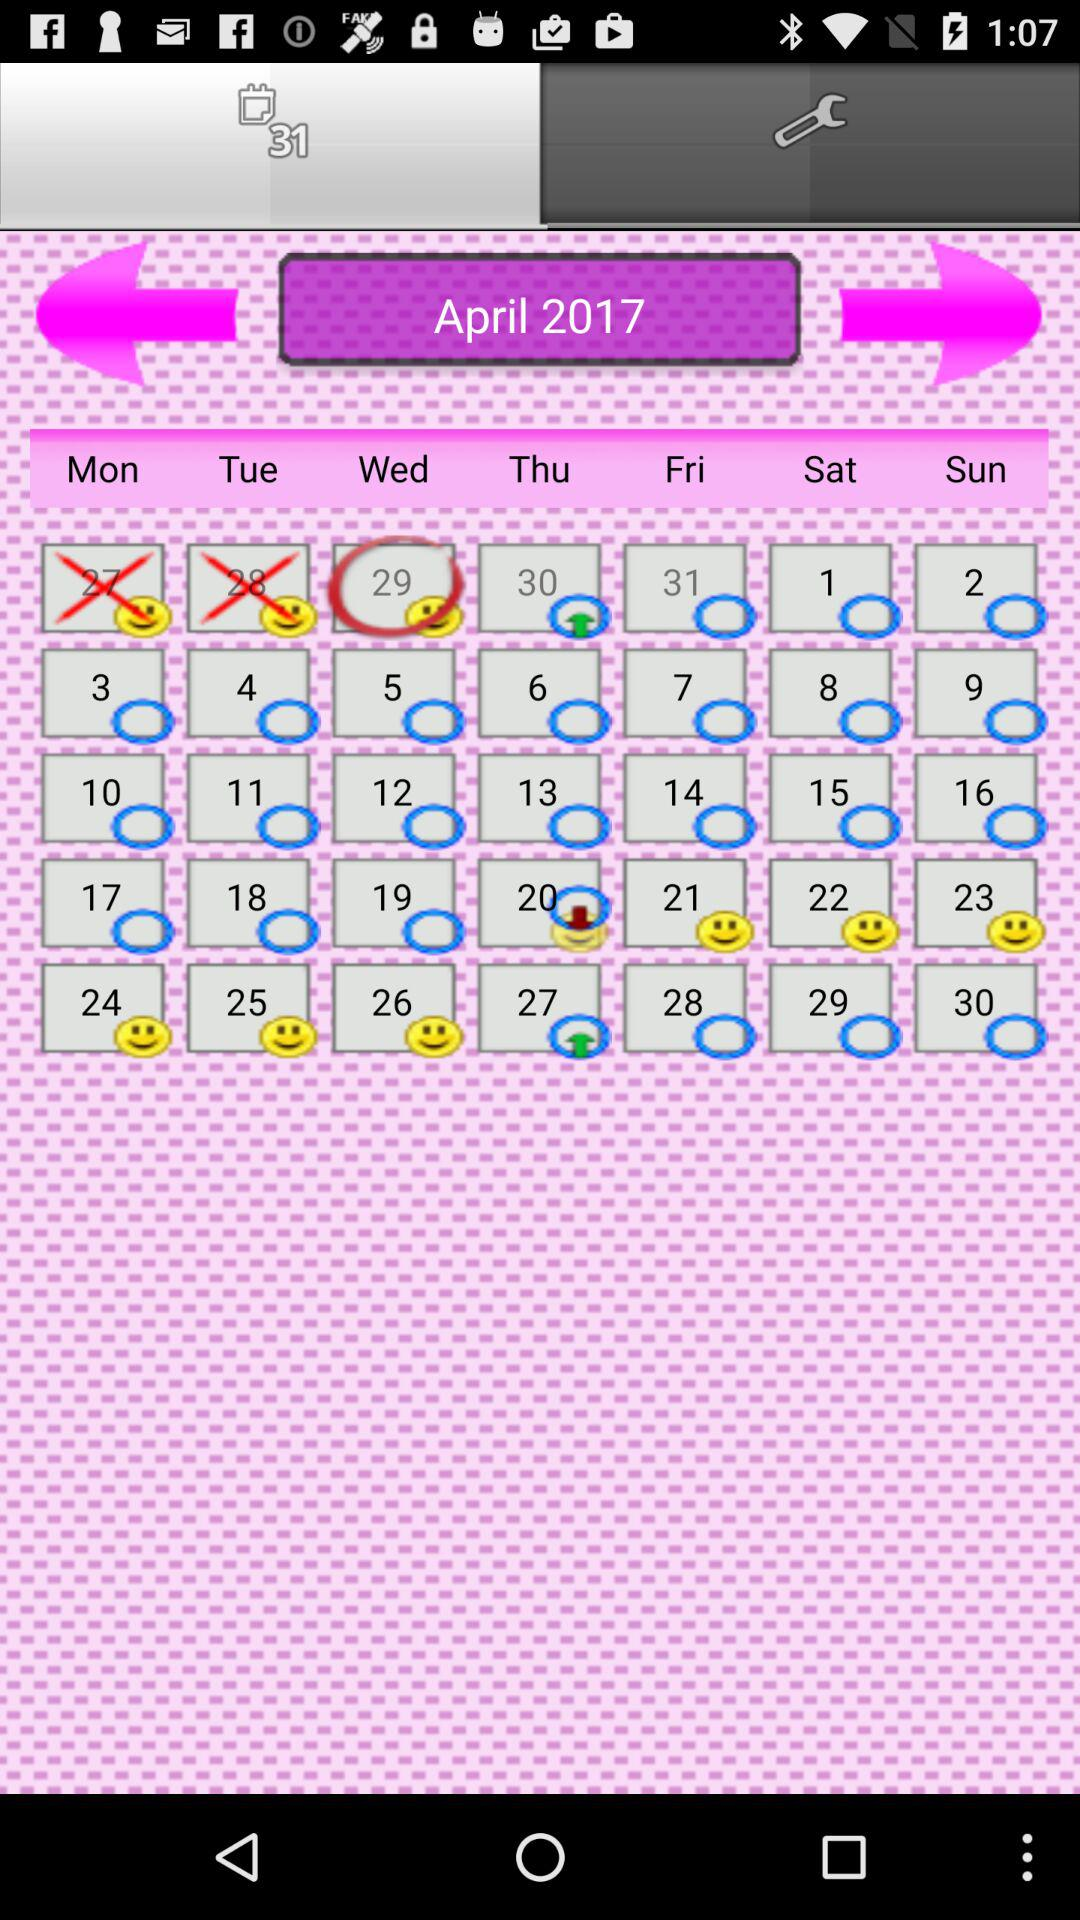What date is marked as crossed? The dates that are marked as crossed are 27 and 28. 